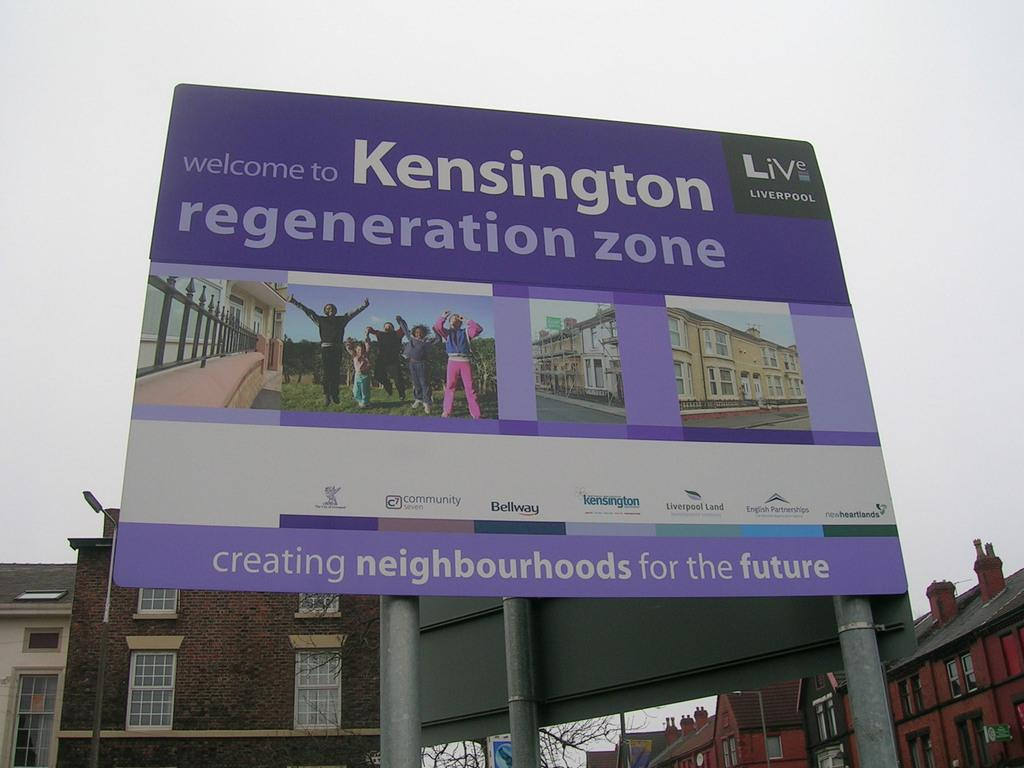<image>
Provide a brief description of the given image. The advertised company is creating neighbourhoods for the future. 